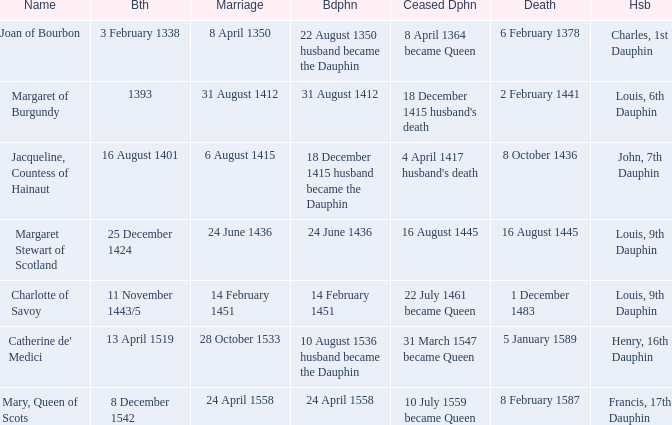Could you parse the entire table? {'header': ['Name', 'Bth', 'Marriage', 'Bdphn', 'Ceased Dphn', 'Death', 'Hsb'], 'rows': [['Joan of Bourbon', '3 February 1338', '8 April 1350', '22 August 1350 husband became the Dauphin', '8 April 1364 became Queen', '6 February 1378', 'Charles, 1st Dauphin'], ['Margaret of Burgundy', '1393', '31 August 1412', '31 August 1412', "18 December 1415 husband's death", '2 February 1441', 'Louis, 6th Dauphin'], ['Jacqueline, Countess of Hainaut', '16 August 1401', '6 August 1415', '18 December 1415 husband became the Dauphin', "4 April 1417 husband's death", '8 October 1436', 'John, 7th Dauphin'], ['Margaret Stewart of Scotland', '25 December 1424', '24 June 1436', '24 June 1436', '16 August 1445', '16 August 1445', 'Louis, 9th Dauphin'], ['Charlotte of Savoy', '11 November 1443/5', '14 February 1451', '14 February 1451', '22 July 1461 became Queen', '1 December 1483', 'Louis, 9th Dauphin'], ["Catherine de' Medici", '13 April 1519', '28 October 1533', '10 August 1536 husband became the Dauphin', '31 March 1547 became Queen', '5 January 1589', 'Henry, 16th Dauphin'], ['Mary, Queen of Scots', '8 December 1542', '24 April 1558', '24 April 1558', '10 July 1559 became Queen', '8 February 1587', 'Francis, 17th Dauphin']]} Who is the husband when ceased to be dauphine is 22 july 1461 became queen? Louis, 9th Dauphin. 